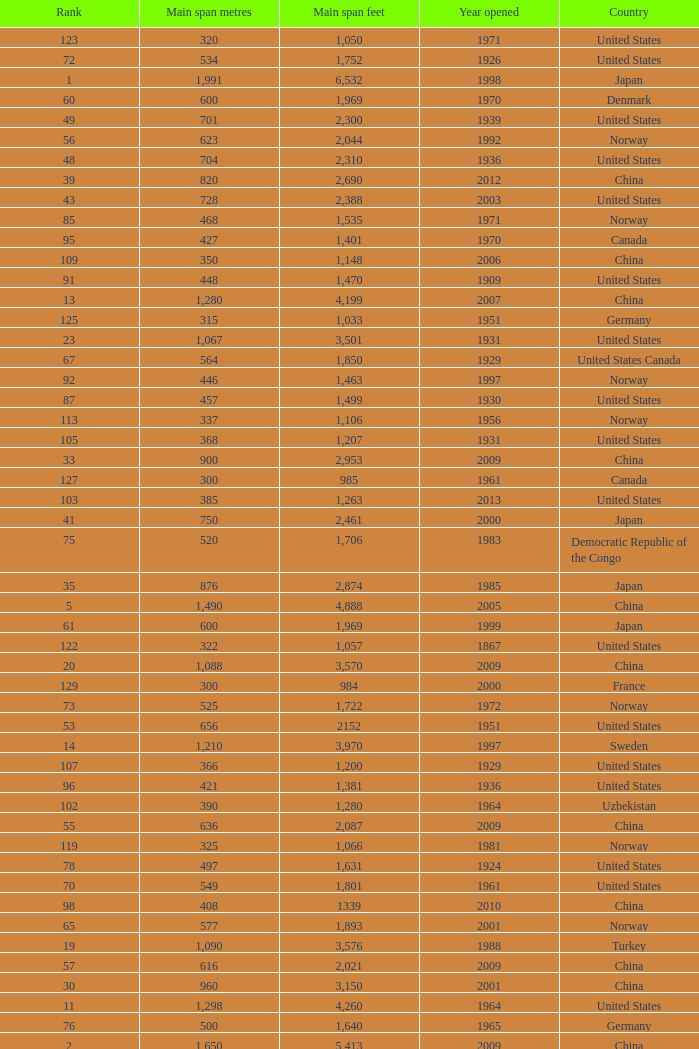What is the main span in feet from a year of 2009 or more recent with a rank less than 94 and 1,310 main span metres? 4298.0. 